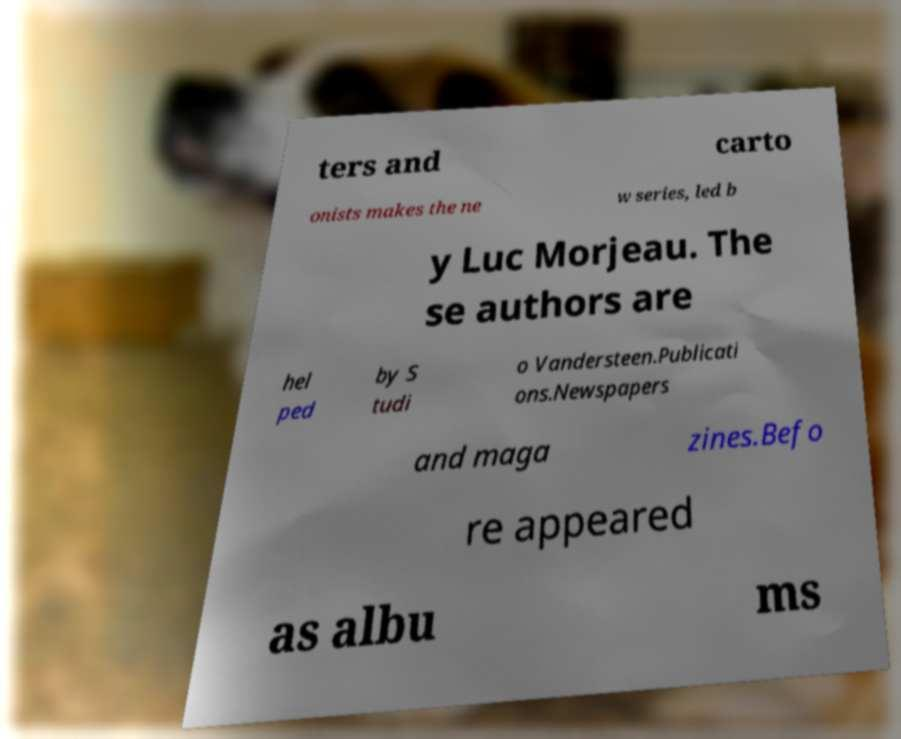Could you assist in decoding the text presented in this image and type it out clearly? ters and carto onists makes the ne w series, led b y Luc Morjeau. The se authors are hel ped by S tudi o Vandersteen.Publicati ons.Newspapers and maga zines.Befo re appeared as albu ms 